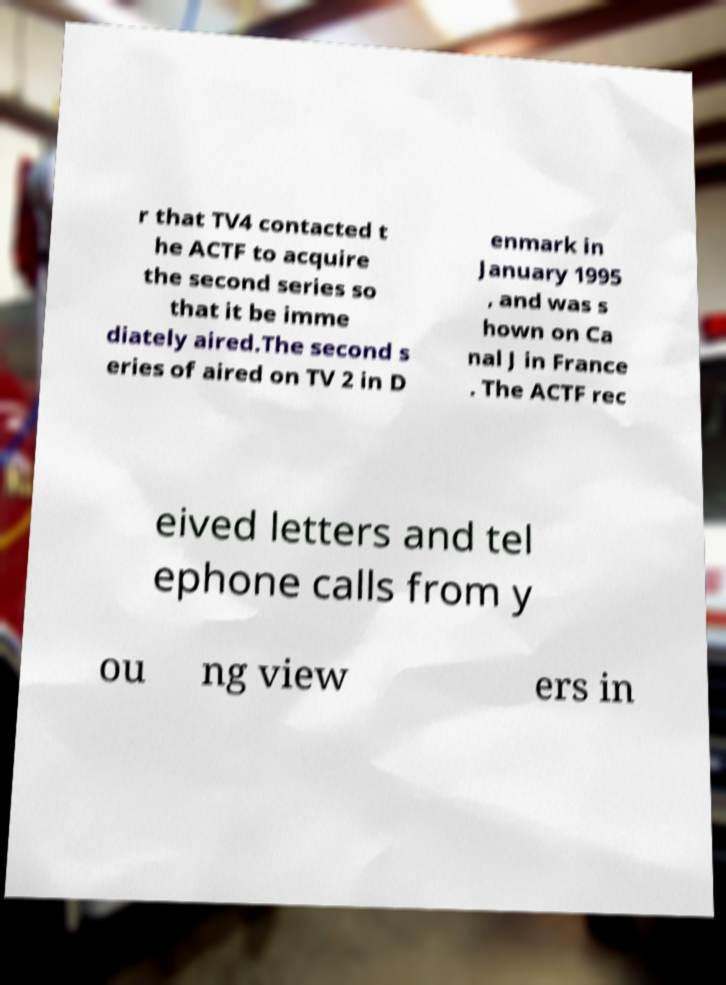I need the written content from this picture converted into text. Can you do that? r that TV4 contacted t he ACTF to acquire the second series so that it be imme diately aired.The second s eries of aired on TV 2 in D enmark in January 1995 , and was s hown on Ca nal J in France . The ACTF rec eived letters and tel ephone calls from y ou ng view ers in 